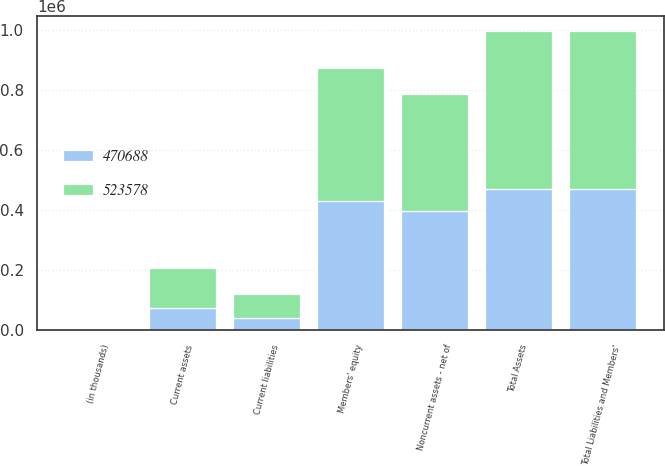Convert chart to OTSL. <chart><loc_0><loc_0><loc_500><loc_500><stacked_bar_chart><ecel><fcel>(in thousands)<fcel>Current assets<fcel>Noncurrent assets - net of<fcel>Total Assets<fcel>Current liabilities<fcel>Members' equity<fcel>Total Liabilities and Members'<nl><fcel>523578<fcel>2004<fcel>134596<fcel>388982<fcel>523578<fcel>80310<fcel>443268<fcel>523578<nl><fcel>470688<fcel>2003<fcel>73604<fcel>397084<fcel>470688<fcel>39855<fcel>430833<fcel>470688<nl></chart> 